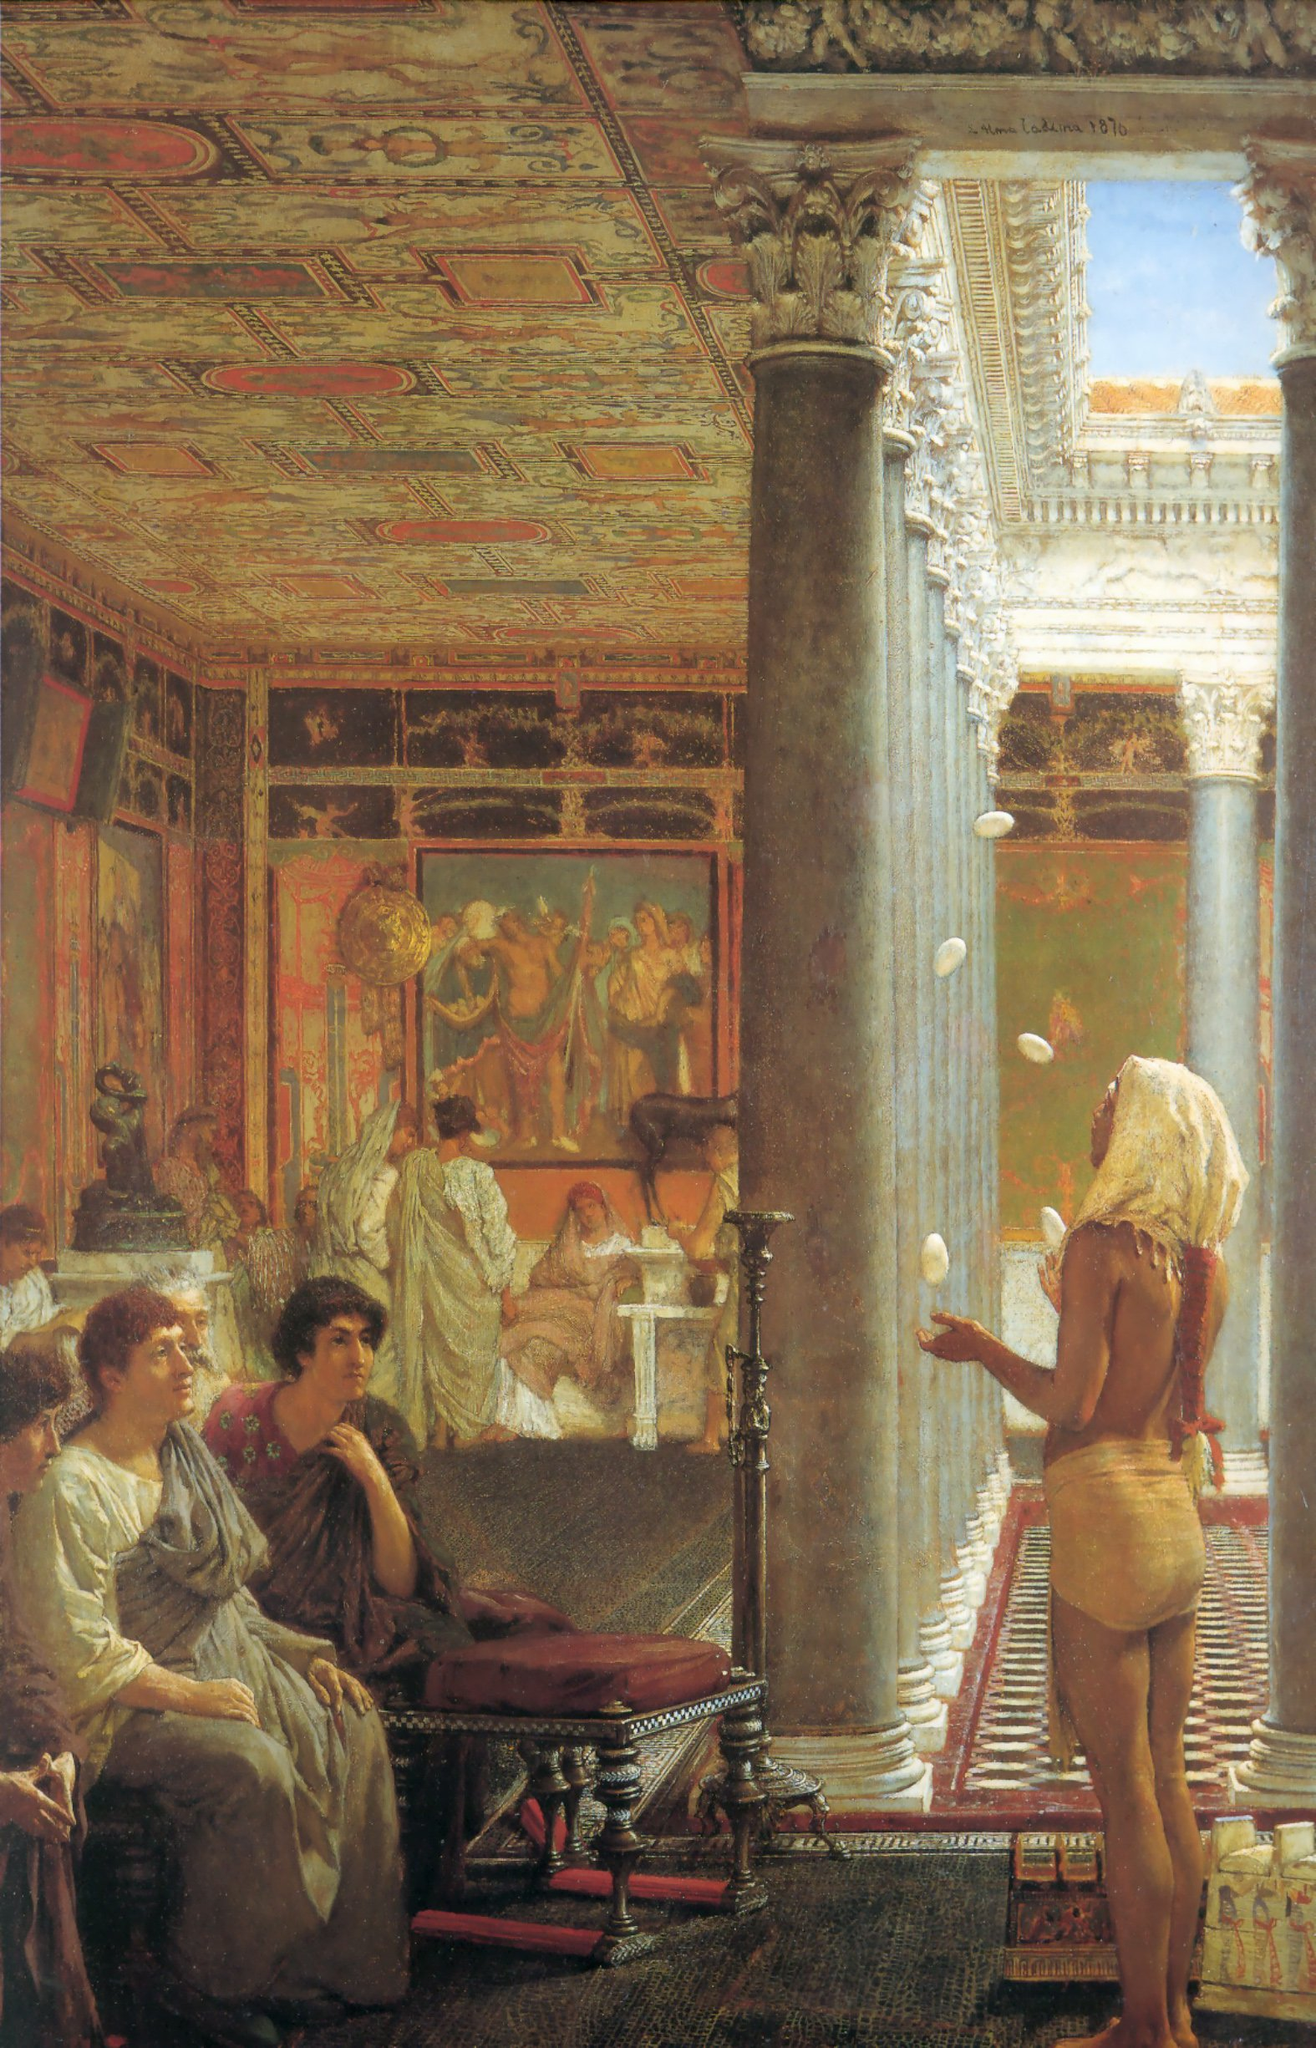Can you describe the main activities taking place in the scene? The scene in the painting appears to depict a gathering in a luxurious room, possibly a hall of a grand Roman palace. There are figures engaged in various activities: in the foreground, women are seated, seemingly engrossed in conversation or watching an event. To the right, a figure is juggling, drawing attention with his skill. In the background, there's a group of individuals involved in a discussion or possibly a ceremony, given their elaborate clothing and the context of the room. The entire setting is bustling with life and interaction, each figure contributing to the rich tapestry of the scene. Can you provide more details about the juggler on the right side? The juggler, positioned towards the right side of the painting, stands out against the grand architectural backdrop. He is dressed minimally in a loincloth and his physique suggests he is a performer or servant. He is skillfully juggling several white objects, possibly balls or eggs, which are suspended mid-air, capturing a moment of action and dexterity. His presence adds a dynamic contrast to the otherwise serene and socially engaging atmosphere of the other characters in the scene. This suggests a blend of entertainment and daily life within the luxurious setting. What might the people in the background be discussing or doing? The individuals in the background are likely participating in a scholarly or philosophical discussion, or they could be involved in a ceremonial activity. Their attire suggests a historical or classical context, and their gathered positioning around a figure who might be a storyteller, philosopher, or leader indicates an exchange of ideas or important dialogue. The ornate decorations and classical paintings surrounding them enhance the notion that this scene is set within a learned and culturally rich environment, where discussions of art, philosophy, or even political matters could unfold. 